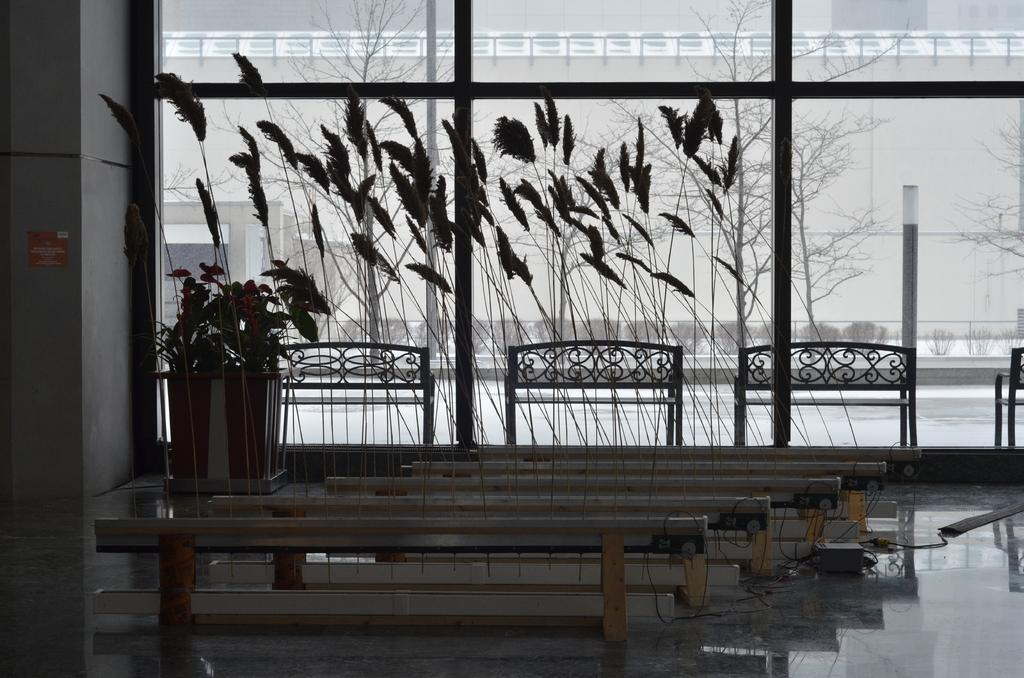What type of objects can be seen in the image? There are feathers and a pot in the image. Can you describe the feathers in the image? The feathers are the main focus in the image, but no further details are provided. What is the purpose of the pot in the image? The purpose of the pot is not specified in the provided facts. How many times does the person kick the feathers in the image? There is no person or kicking action present in the image; it only features feathers and a pot. 